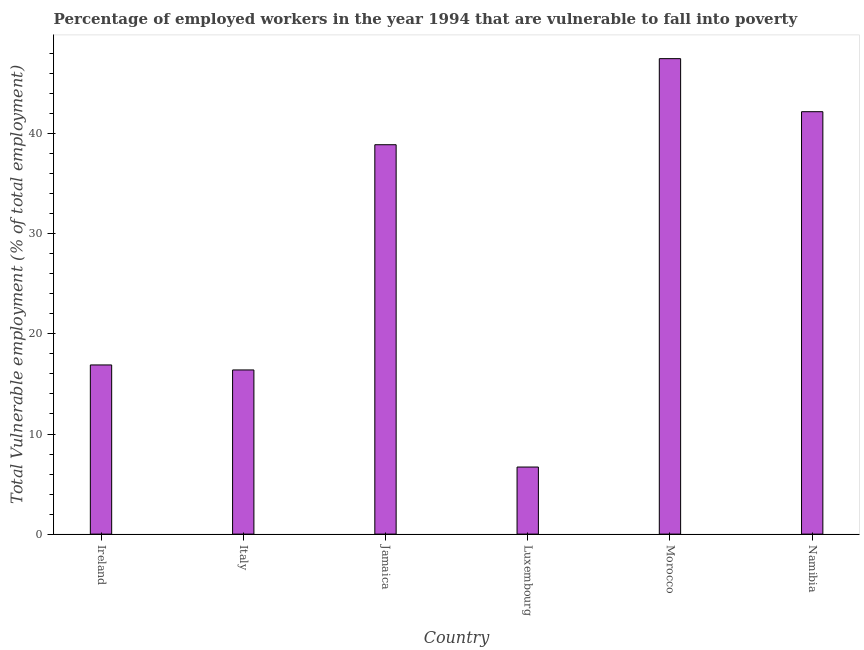Does the graph contain grids?
Your answer should be compact. No. What is the title of the graph?
Offer a very short reply. Percentage of employed workers in the year 1994 that are vulnerable to fall into poverty. What is the label or title of the Y-axis?
Your response must be concise. Total Vulnerable employment (% of total employment). What is the total vulnerable employment in Luxembourg?
Ensure brevity in your answer.  6.7. Across all countries, what is the maximum total vulnerable employment?
Your answer should be very brief. 47.5. Across all countries, what is the minimum total vulnerable employment?
Your response must be concise. 6.7. In which country was the total vulnerable employment maximum?
Make the answer very short. Morocco. In which country was the total vulnerable employment minimum?
Make the answer very short. Luxembourg. What is the sum of the total vulnerable employment?
Provide a succinct answer. 168.6. What is the average total vulnerable employment per country?
Offer a terse response. 28.1. What is the median total vulnerable employment?
Your response must be concise. 27.9. What is the ratio of the total vulnerable employment in Morocco to that in Namibia?
Keep it short and to the point. 1.13. What is the difference between the highest and the second highest total vulnerable employment?
Your response must be concise. 5.3. Is the sum of the total vulnerable employment in Italy and Luxembourg greater than the maximum total vulnerable employment across all countries?
Offer a very short reply. No. What is the difference between the highest and the lowest total vulnerable employment?
Provide a succinct answer. 40.8. How many bars are there?
Provide a short and direct response. 6. Are all the bars in the graph horizontal?
Offer a terse response. No. How many countries are there in the graph?
Offer a very short reply. 6. What is the difference between two consecutive major ticks on the Y-axis?
Your answer should be very brief. 10. Are the values on the major ticks of Y-axis written in scientific E-notation?
Offer a terse response. No. What is the Total Vulnerable employment (% of total employment) in Ireland?
Ensure brevity in your answer.  16.9. What is the Total Vulnerable employment (% of total employment) of Italy?
Provide a short and direct response. 16.4. What is the Total Vulnerable employment (% of total employment) in Jamaica?
Provide a short and direct response. 38.9. What is the Total Vulnerable employment (% of total employment) of Luxembourg?
Make the answer very short. 6.7. What is the Total Vulnerable employment (% of total employment) in Morocco?
Offer a terse response. 47.5. What is the Total Vulnerable employment (% of total employment) in Namibia?
Make the answer very short. 42.2. What is the difference between the Total Vulnerable employment (% of total employment) in Ireland and Luxembourg?
Your response must be concise. 10.2. What is the difference between the Total Vulnerable employment (% of total employment) in Ireland and Morocco?
Give a very brief answer. -30.6. What is the difference between the Total Vulnerable employment (% of total employment) in Ireland and Namibia?
Provide a short and direct response. -25.3. What is the difference between the Total Vulnerable employment (% of total employment) in Italy and Jamaica?
Provide a short and direct response. -22.5. What is the difference between the Total Vulnerable employment (% of total employment) in Italy and Luxembourg?
Offer a very short reply. 9.7. What is the difference between the Total Vulnerable employment (% of total employment) in Italy and Morocco?
Give a very brief answer. -31.1. What is the difference between the Total Vulnerable employment (% of total employment) in Italy and Namibia?
Your response must be concise. -25.8. What is the difference between the Total Vulnerable employment (% of total employment) in Jamaica and Luxembourg?
Give a very brief answer. 32.2. What is the difference between the Total Vulnerable employment (% of total employment) in Jamaica and Namibia?
Make the answer very short. -3.3. What is the difference between the Total Vulnerable employment (% of total employment) in Luxembourg and Morocco?
Ensure brevity in your answer.  -40.8. What is the difference between the Total Vulnerable employment (% of total employment) in Luxembourg and Namibia?
Your answer should be compact. -35.5. What is the ratio of the Total Vulnerable employment (% of total employment) in Ireland to that in Jamaica?
Provide a succinct answer. 0.43. What is the ratio of the Total Vulnerable employment (% of total employment) in Ireland to that in Luxembourg?
Give a very brief answer. 2.52. What is the ratio of the Total Vulnerable employment (% of total employment) in Ireland to that in Morocco?
Your answer should be very brief. 0.36. What is the ratio of the Total Vulnerable employment (% of total employment) in Italy to that in Jamaica?
Provide a succinct answer. 0.42. What is the ratio of the Total Vulnerable employment (% of total employment) in Italy to that in Luxembourg?
Keep it short and to the point. 2.45. What is the ratio of the Total Vulnerable employment (% of total employment) in Italy to that in Morocco?
Make the answer very short. 0.34. What is the ratio of the Total Vulnerable employment (% of total employment) in Italy to that in Namibia?
Make the answer very short. 0.39. What is the ratio of the Total Vulnerable employment (% of total employment) in Jamaica to that in Luxembourg?
Keep it short and to the point. 5.81. What is the ratio of the Total Vulnerable employment (% of total employment) in Jamaica to that in Morocco?
Give a very brief answer. 0.82. What is the ratio of the Total Vulnerable employment (% of total employment) in Jamaica to that in Namibia?
Ensure brevity in your answer.  0.92. What is the ratio of the Total Vulnerable employment (% of total employment) in Luxembourg to that in Morocco?
Give a very brief answer. 0.14. What is the ratio of the Total Vulnerable employment (% of total employment) in Luxembourg to that in Namibia?
Offer a terse response. 0.16. What is the ratio of the Total Vulnerable employment (% of total employment) in Morocco to that in Namibia?
Give a very brief answer. 1.13. 